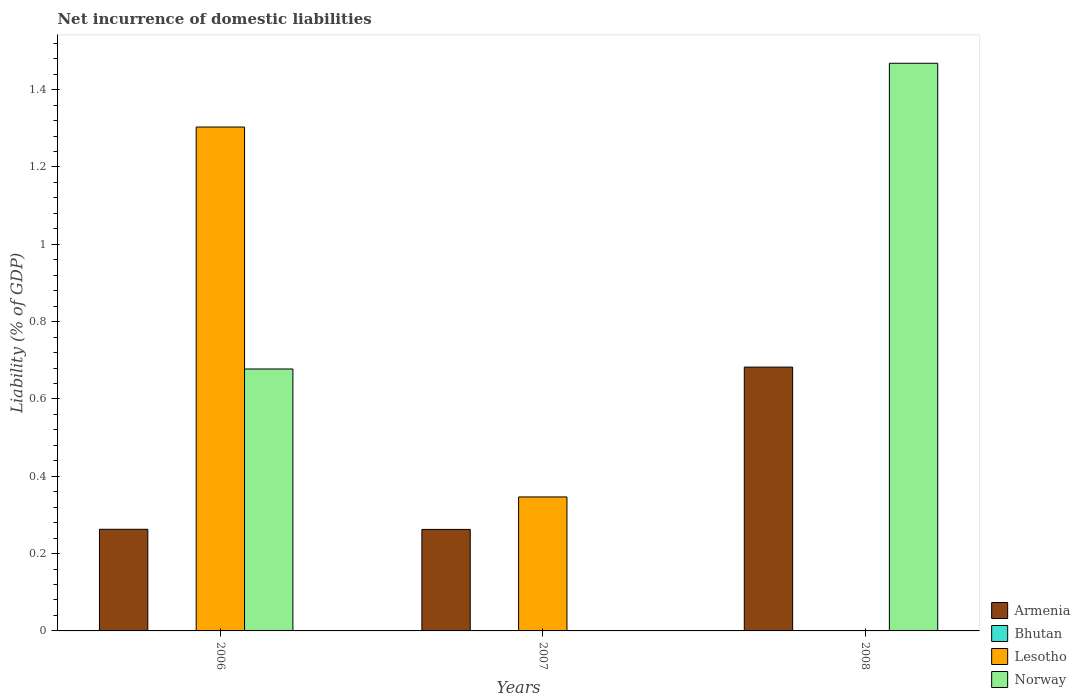How many groups of bars are there?
Make the answer very short. 3. Are the number of bars per tick equal to the number of legend labels?
Ensure brevity in your answer.  No. Are the number of bars on each tick of the X-axis equal?
Keep it short and to the point. No. How many bars are there on the 3rd tick from the left?
Make the answer very short. 2. What is the net incurrence of domestic liabilities in Norway in 2008?
Your response must be concise. 1.47. Across all years, what is the maximum net incurrence of domestic liabilities in Armenia?
Your response must be concise. 0.68. Across all years, what is the minimum net incurrence of domestic liabilities in Armenia?
Your answer should be very brief. 0.26. In which year was the net incurrence of domestic liabilities in Armenia maximum?
Your response must be concise. 2008. What is the total net incurrence of domestic liabilities in Lesotho in the graph?
Offer a terse response. 1.65. What is the difference between the net incurrence of domestic liabilities in Norway in 2006 and that in 2008?
Give a very brief answer. -0.79. What is the difference between the net incurrence of domestic liabilities in Norway in 2008 and the net incurrence of domestic liabilities in Lesotho in 2006?
Provide a short and direct response. 0.16. What is the average net incurrence of domestic liabilities in Norway per year?
Your answer should be compact. 0.72. In the year 2006, what is the difference between the net incurrence of domestic liabilities in Lesotho and net incurrence of domestic liabilities in Armenia?
Offer a terse response. 1.04. What is the difference between the highest and the lowest net incurrence of domestic liabilities in Lesotho?
Your response must be concise. 1.3. Is the sum of the net incurrence of domestic liabilities in Armenia in 2006 and 2007 greater than the maximum net incurrence of domestic liabilities in Lesotho across all years?
Offer a very short reply. No. Is it the case that in every year, the sum of the net incurrence of domestic liabilities in Bhutan and net incurrence of domestic liabilities in Armenia is greater than the sum of net incurrence of domestic liabilities in Lesotho and net incurrence of domestic liabilities in Norway?
Make the answer very short. No. How many years are there in the graph?
Keep it short and to the point. 3. How many legend labels are there?
Offer a terse response. 4. What is the title of the graph?
Provide a short and direct response. Net incurrence of domestic liabilities. What is the label or title of the Y-axis?
Offer a very short reply. Liability (% of GDP). What is the Liability (% of GDP) in Armenia in 2006?
Your answer should be compact. 0.26. What is the Liability (% of GDP) of Lesotho in 2006?
Give a very brief answer. 1.3. What is the Liability (% of GDP) in Norway in 2006?
Provide a short and direct response. 0.68. What is the Liability (% of GDP) in Armenia in 2007?
Keep it short and to the point. 0.26. What is the Liability (% of GDP) in Lesotho in 2007?
Offer a very short reply. 0.35. What is the Liability (% of GDP) of Armenia in 2008?
Ensure brevity in your answer.  0.68. What is the Liability (% of GDP) in Norway in 2008?
Give a very brief answer. 1.47. Across all years, what is the maximum Liability (% of GDP) of Armenia?
Your response must be concise. 0.68. Across all years, what is the maximum Liability (% of GDP) in Lesotho?
Your response must be concise. 1.3. Across all years, what is the maximum Liability (% of GDP) of Norway?
Your answer should be compact. 1.47. Across all years, what is the minimum Liability (% of GDP) in Armenia?
Provide a short and direct response. 0.26. Across all years, what is the minimum Liability (% of GDP) in Lesotho?
Give a very brief answer. 0. What is the total Liability (% of GDP) in Armenia in the graph?
Offer a terse response. 1.21. What is the total Liability (% of GDP) in Lesotho in the graph?
Offer a very short reply. 1.65. What is the total Liability (% of GDP) of Norway in the graph?
Your answer should be compact. 2.15. What is the difference between the Liability (% of GDP) of Lesotho in 2006 and that in 2007?
Your answer should be very brief. 0.96. What is the difference between the Liability (% of GDP) in Armenia in 2006 and that in 2008?
Ensure brevity in your answer.  -0.42. What is the difference between the Liability (% of GDP) in Norway in 2006 and that in 2008?
Ensure brevity in your answer.  -0.79. What is the difference between the Liability (% of GDP) of Armenia in 2007 and that in 2008?
Your answer should be compact. -0.42. What is the difference between the Liability (% of GDP) of Armenia in 2006 and the Liability (% of GDP) of Lesotho in 2007?
Your answer should be compact. -0.08. What is the difference between the Liability (% of GDP) of Armenia in 2006 and the Liability (% of GDP) of Norway in 2008?
Ensure brevity in your answer.  -1.21. What is the difference between the Liability (% of GDP) of Lesotho in 2006 and the Liability (% of GDP) of Norway in 2008?
Offer a very short reply. -0.17. What is the difference between the Liability (% of GDP) of Armenia in 2007 and the Liability (% of GDP) of Norway in 2008?
Give a very brief answer. -1.21. What is the difference between the Liability (% of GDP) in Lesotho in 2007 and the Liability (% of GDP) in Norway in 2008?
Provide a short and direct response. -1.12. What is the average Liability (% of GDP) in Armenia per year?
Your response must be concise. 0.4. What is the average Liability (% of GDP) of Lesotho per year?
Your answer should be compact. 0.55. What is the average Liability (% of GDP) in Norway per year?
Give a very brief answer. 0.72. In the year 2006, what is the difference between the Liability (% of GDP) in Armenia and Liability (% of GDP) in Lesotho?
Provide a succinct answer. -1.04. In the year 2006, what is the difference between the Liability (% of GDP) of Armenia and Liability (% of GDP) of Norway?
Provide a succinct answer. -0.41. In the year 2006, what is the difference between the Liability (% of GDP) in Lesotho and Liability (% of GDP) in Norway?
Make the answer very short. 0.63. In the year 2007, what is the difference between the Liability (% of GDP) in Armenia and Liability (% of GDP) in Lesotho?
Your answer should be compact. -0.08. In the year 2008, what is the difference between the Liability (% of GDP) of Armenia and Liability (% of GDP) of Norway?
Your answer should be very brief. -0.79. What is the ratio of the Liability (% of GDP) in Armenia in 2006 to that in 2007?
Ensure brevity in your answer.  1. What is the ratio of the Liability (% of GDP) of Lesotho in 2006 to that in 2007?
Keep it short and to the point. 3.76. What is the ratio of the Liability (% of GDP) in Armenia in 2006 to that in 2008?
Give a very brief answer. 0.39. What is the ratio of the Liability (% of GDP) in Norway in 2006 to that in 2008?
Your answer should be very brief. 0.46. What is the ratio of the Liability (% of GDP) of Armenia in 2007 to that in 2008?
Ensure brevity in your answer.  0.38. What is the difference between the highest and the second highest Liability (% of GDP) in Armenia?
Make the answer very short. 0.42. What is the difference between the highest and the lowest Liability (% of GDP) in Armenia?
Offer a terse response. 0.42. What is the difference between the highest and the lowest Liability (% of GDP) in Lesotho?
Keep it short and to the point. 1.3. What is the difference between the highest and the lowest Liability (% of GDP) in Norway?
Offer a very short reply. 1.47. 